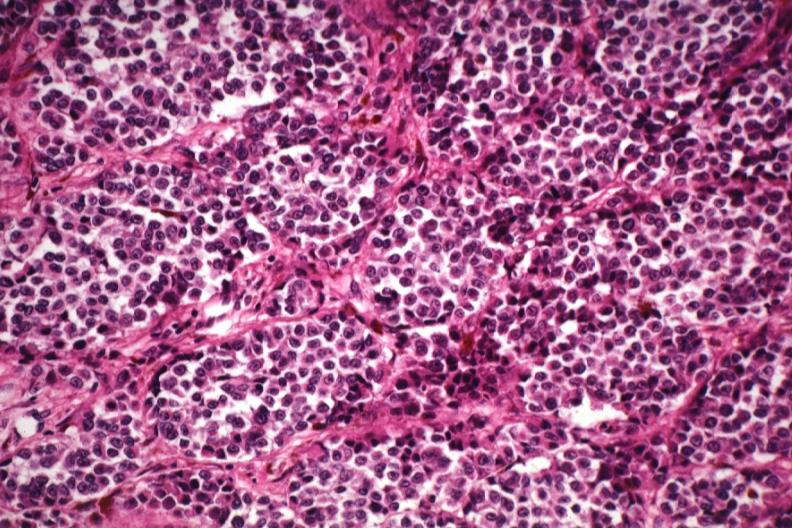does this image show good tumor cells with little pigment except in melanophores?
Answer the question using a single word or phrase. Yes 